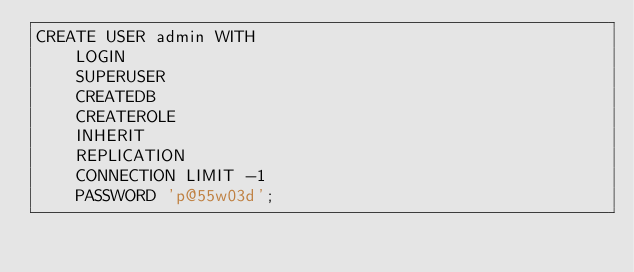Convert code to text. <code><loc_0><loc_0><loc_500><loc_500><_SQL_>CREATE USER admin WITH
	LOGIN
	SUPERUSER
	CREATEDB
	CREATEROLE
	INHERIT
	REPLICATION
	CONNECTION LIMIT -1
	PASSWORD 'p@55w03d';</code> 